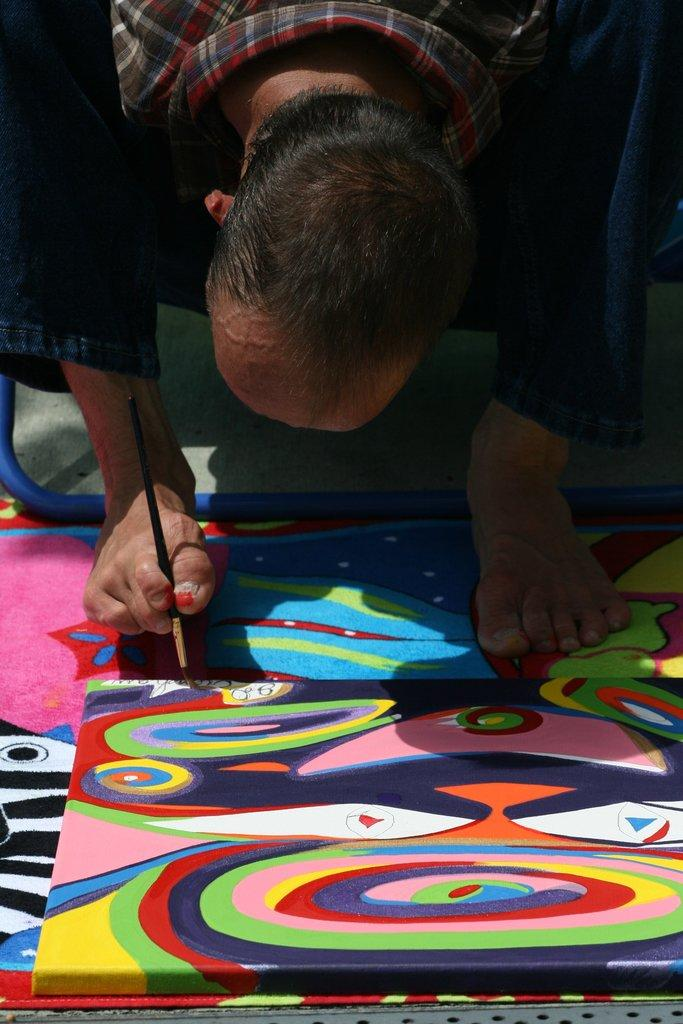What is the main subject of the image? There is a person in the image. What is the person doing with the brush? The person is holding a brush with their leg. What is the person painting on? The person is painting on a board. What rate is the person's belief in the purpose of painting with their leg progressing at in the image? There is no information provided about the person's belief or the purpose of their actions, and the rate of progress cannot be determined from the image. 